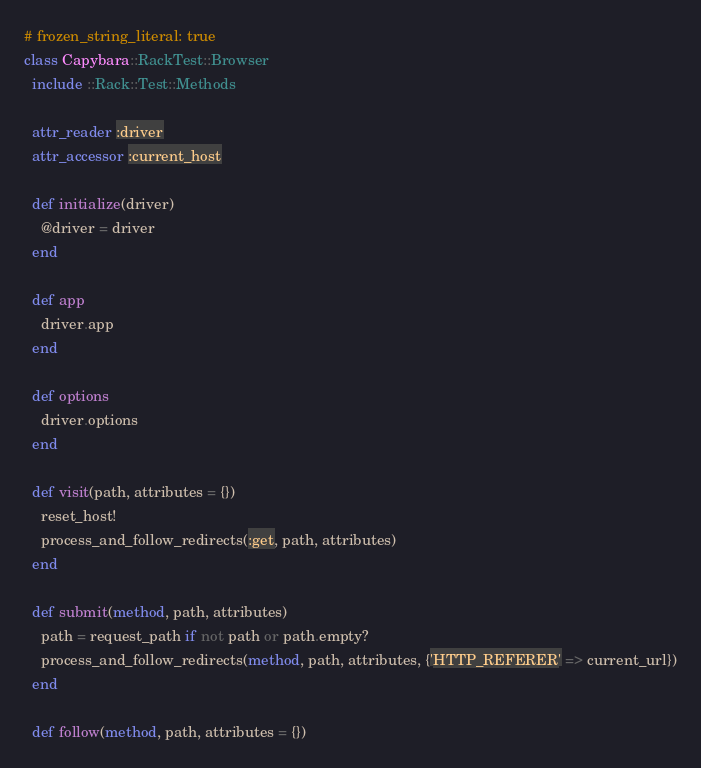Convert code to text. <code><loc_0><loc_0><loc_500><loc_500><_Ruby_># frozen_string_literal: true
class Capybara::RackTest::Browser
  include ::Rack::Test::Methods

  attr_reader :driver
  attr_accessor :current_host

  def initialize(driver)
    @driver = driver
  end

  def app
    driver.app
  end

  def options
    driver.options
  end

  def visit(path, attributes = {})
    reset_host!
    process_and_follow_redirects(:get, path, attributes)
  end

  def submit(method, path, attributes)
    path = request_path if not path or path.empty?
    process_and_follow_redirects(method, path, attributes, {'HTTP_REFERER' => current_url})
  end

  def follow(method, path, attributes = {})</code> 